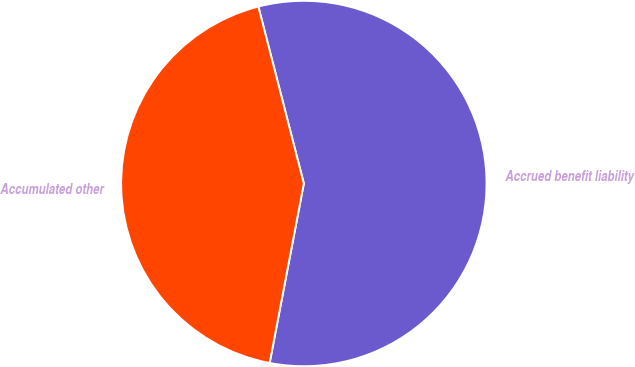Convert chart to OTSL. <chart><loc_0><loc_0><loc_500><loc_500><pie_chart><fcel>Accrued benefit liability<fcel>Accumulated other<nl><fcel>57.0%<fcel>43.0%<nl></chart> 